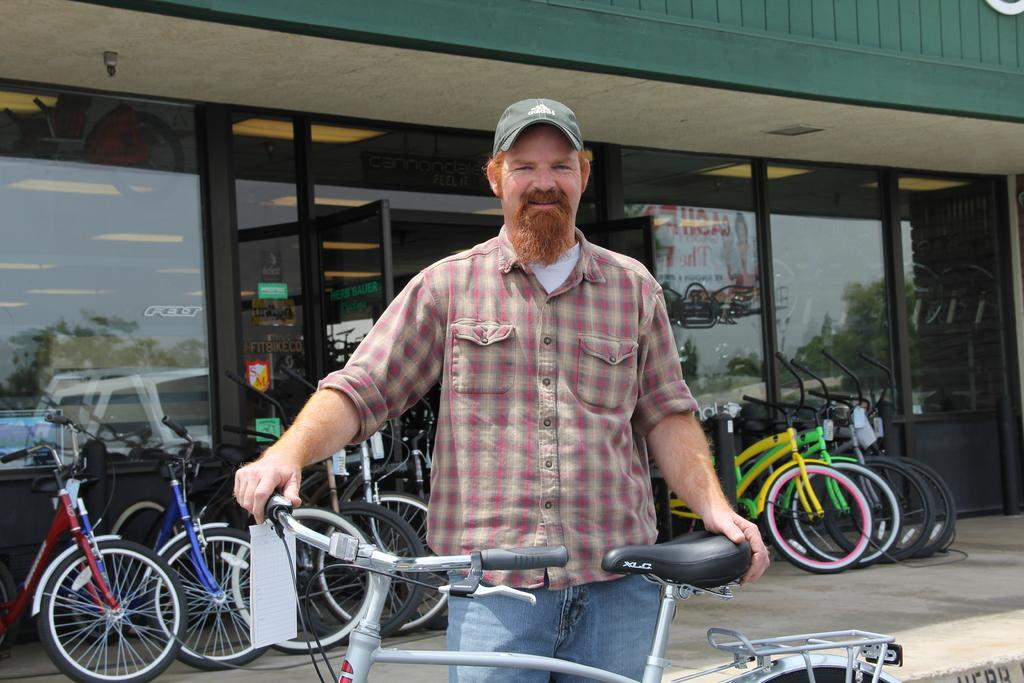What is the main subject of the image? There is a person in the image. What is the person doing in the image? The person is standing and holding a bicycle. Are there any other bicycles visible in the image? Yes, there are other bicycles visible in the image. What can be seen in the background of the image? There is a bicycle store in the background of the image. What type of spark can be seen coming from the person's hand in the image? There is no spark visible in the image; the person is simply holding a bicycle. 